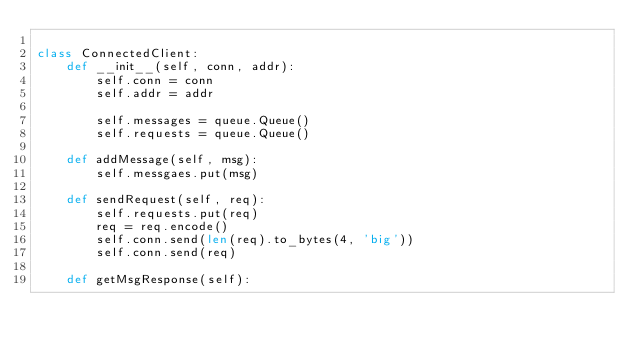Convert code to text. <code><loc_0><loc_0><loc_500><loc_500><_Python_>
class ConnectedClient:
    def __init__(self, conn, addr):
        self.conn = conn
        self.addr = addr

        self.messages = queue.Queue()
        self.requests = queue.Queue()

    def addMessage(self, msg):
        self.messgaes.put(msg)

    def sendRequest(self, req):
        self.requests.put(req)
        req = req.encode()
        self.conn.send(len(req).to_bytes(4, 'big'))
        self.conn.send(req)

    def getMsgResponse(self):</code> 